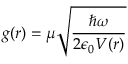Convert formula to latex. <formula><loc_0><loc_0><loc_500><loc_500>g ( r ) = \mu \sqrt { \frac { \hbar { \omega } } { 2 \epsilon _ { 0 } V ( r ) } }</formula> 